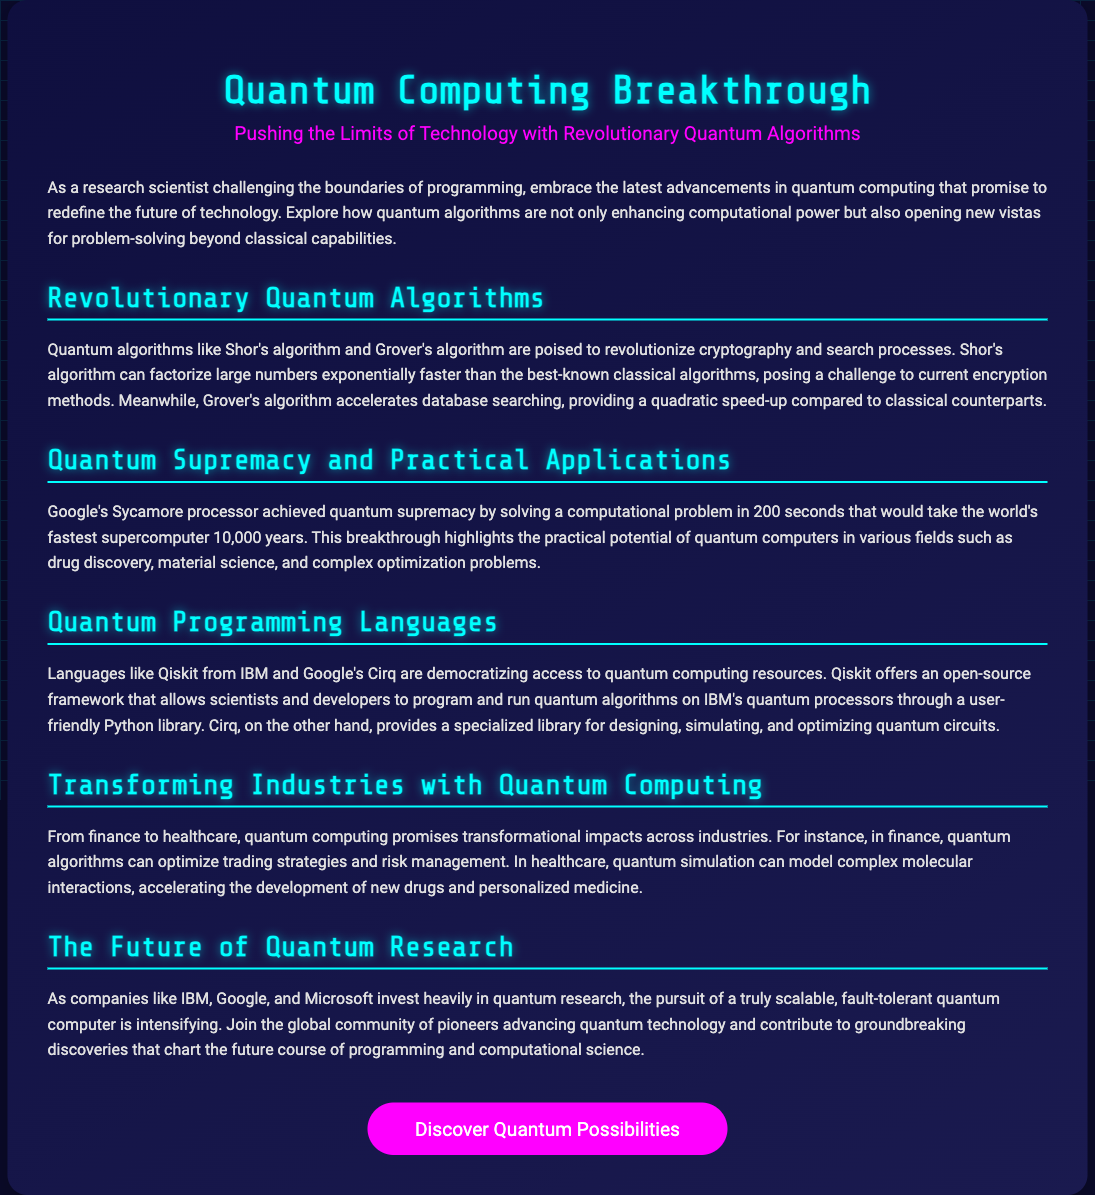What is the title of the advertisement? The title of the advertisement is prominently displayed at the top of the document, introducing the main topic.
Answer: Quantum Computing Breakthrough What are two examples of revolutionary quantum algorithms mentioned? The advertisement highlights specific algorithms that have significant implications in technology, providing clear examples of their names.
Answer: Shor's algorithm and Grover's algorithm What is the name of Google's quantum processor that achieved quantum supremacy? The name of the processor is specifically mentioned in the section discussing quantum supremacy, indicating a significant achievement in quantum computing.
Answer: Sycamore How long did it take for Sycamore to solve its problem? The time taken by Sycamore is noted in the advertisement, showcasing its performance capability.
Answer: 200 seconds Which programming language is open-source and developed by IBM? The advertisement states specific programming languages that are used in quantum computing, identifying one as open-source and developed by IBM.
Answer: Qiskit In which two industries is quantum computing expected to have a transformational impact? The advertisement discusses the potential effects of quantum computing across different fields, pointing out two specific sectors where this impact is anticipated.
Answer: Finance and healthcare What is the purpose of Qiskit? The advertisement details the functionalities of this programming language, specifying what it is designed to do.
Answer: Program and run quantum algorithms What is the color of the call-to-action button? The advertisement's design choices can be inferred from its visual elements, including the description of the button's color.
Answer: Pink Which companies are mentioned as investing in quantum research? The advertisement lists specific companies that are actively involved in the advancement of quantum technology, highlighting their contributions.
Answer: IBM, Google, and Microsoft 